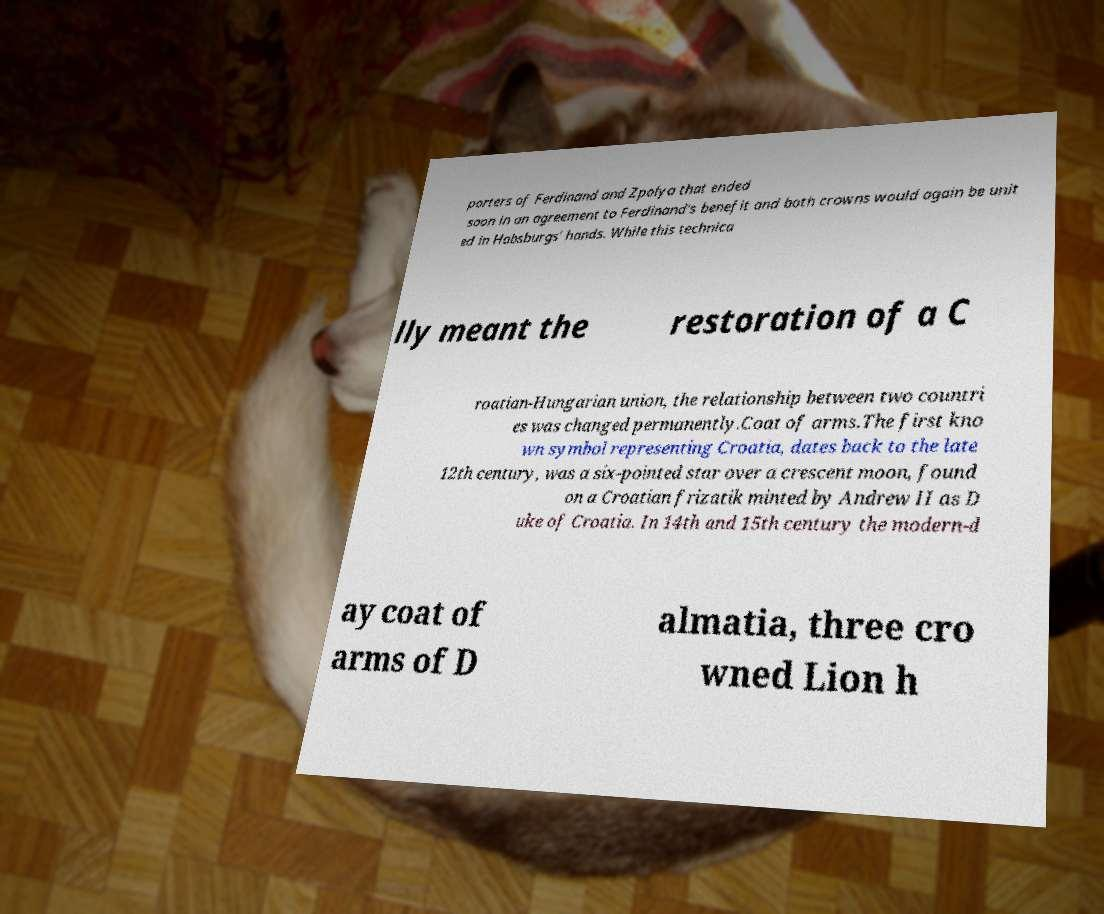What messages or text are displayed in this image? I need them in a readable, typed format. porters of Ferdinand and Zpolya that ended soon in an agreement to Ferdinand's benefit and both crowns would again be unit ed in Habsburgs' hands. While this technica lly meant the restoration of a C roatian-Hungarian union, the relationship between two countri es was changed permanently.Coat of arms.The first kno wn symbol representing Croatia, dates back to the late 12th century, was a six-pointed star over a crescent moon, found on a Croatian frizatik minted by Andrew II as D uke of Croatia. In 14th and 15th century the modern-d ay coat of arms of D almatia, three cro wned Lion h 